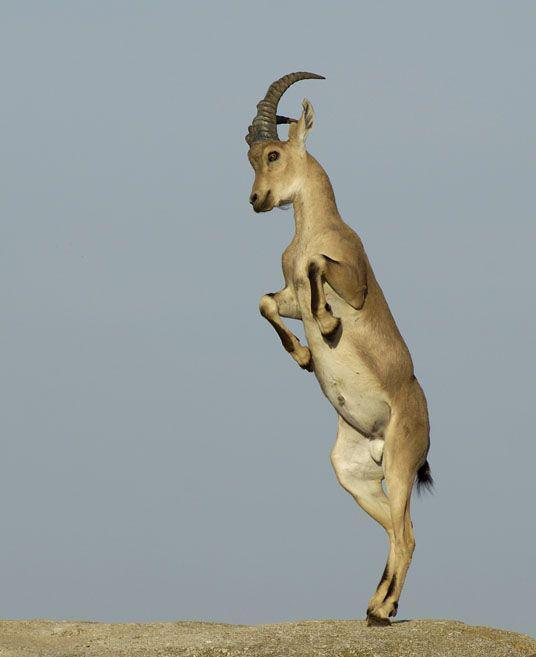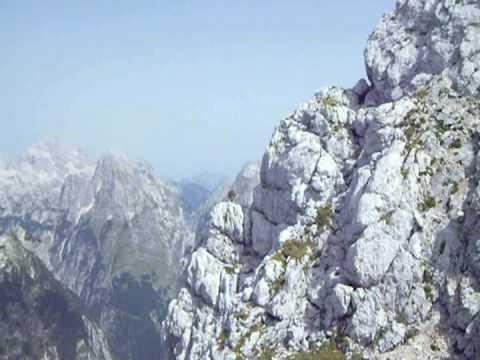The first image is the image on the left, the second image is the image on the right. For the images shown, is this caption "in one of the images, the ram with horns is leaping upwards and racing towards the left side." true? Answer yes or no. Yes. 